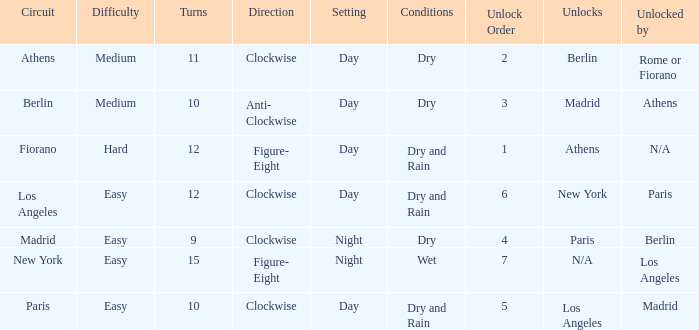How many instances is the unlocked n/a? 1.0. 